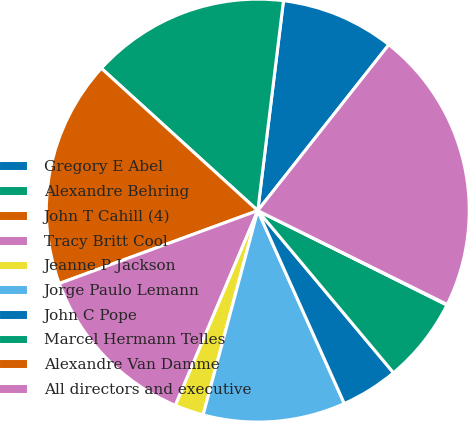Convert chart. <chart><loc_0><loc_0><loc_500><loc_500><pie_chart><fcel>Gregory E Abel<fcel>Alexandre Behring<fcel>John T Cahill (4)<fcel>Tracy Britt Cool<fcel>Jeanne P Jackson<fcel>Jorge Paulo Lemann<fcel>John C Pope<fcel>Marcel Hermann Telles<fcel>Alexandre Van Damme<fcel>All directors and executive<nl><fcel>8.7%<fcel>15.19%<fcel>17.35%<fcel>13.03%<fcel>2.21%<fcel>10.87%<fcel>4.38%<fcel>6.54%<fcel>0.05%<fcel>21.68%<nl></chart> 